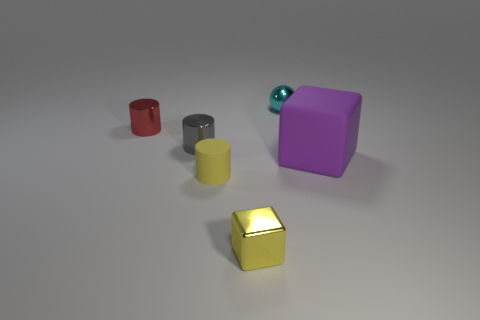What size is the object that is the same material as the big cube?
Ensure brevity in your answer.  Small. What number of small rubber objects have the same color as the shiny cube?
Offer a terse response. 1. Is the number of tiny red metallic objects in front of the gray thing less than the number of yellow cylinders that are behind the purple block?
Provide a short and direct response. No. There is a matte thing left of the cyan shiny thing; does it have the same shape as the small gray metal thing?
Give a very brief answer. Yes. Are there any other things that are made of the same material as the purple object?
Your answer should be very brief. Yes. Do the red cylinder to the left of the matte cylinder and the cyan sphere have the same material?
Your response must be concise. Yes. What material is the cube in front of the tiny matte cylinder on the left side of the tiny metal thing behind the red cylinder made of?
Your answer should be very brief. Metal. How many other objects are the same shape as the yellow rubber object?
Your response must be concise. 2. There is a cylinder in front of the purple object; what is its color?
Your answer should be compact. Yellow. How many tiny cylinders are in front of the cube that is right of the block that is in front of the large object?
Your answer should be very brief. 1. 